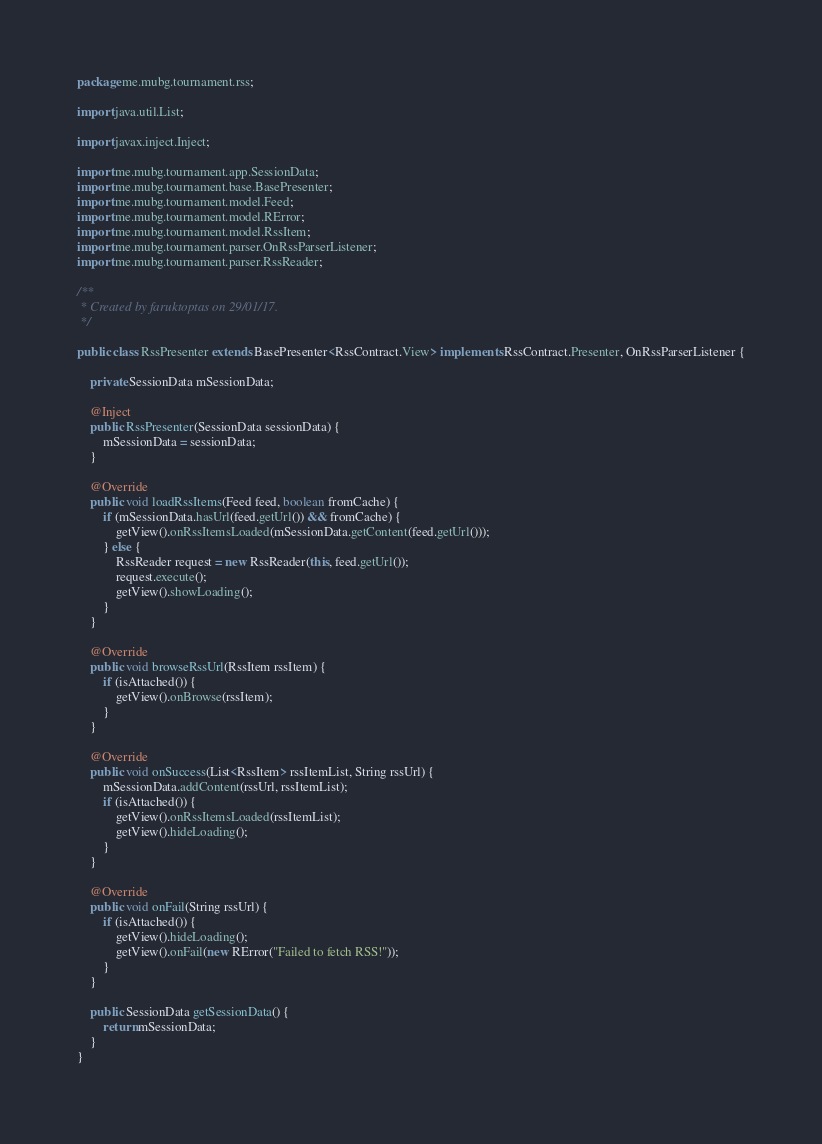<code> <loc_0><loc_0><loc_500><loc_500><_Java_>package me.mubg.tournament.rss;

import java.util.List;

import javax.inject.Inject;

import me.mubg.tournament.app.SessionData;
import me.mubg.tournament.base.BasePresenter;
import me.mubg.tournament.model.Feed;
import me.mubg.tournament.model.RError;
import me.mubg.tournament.model.RssItem;
import me.mubg.tournament.parser.OnRssParserListener;
import me.mubg.tournament.parser.RssReader;

/**
 * Created by faruktoptas on 29/01/17.
 */

public class RssPresenter extends BasePresenter<RssContract.View> implements RssContract.Presenter, OnRssParserListener {

    private SessionData mSessionData;

    @Inject
    public RssPresenter(SessionData sessionData) {
        mSessionData = sessionData;
    }

    @Override
    public void loadRssItems(Feed feed, boolean fromCache) {
        if (mSessionData.hasUrl(feed.getUrl()) && fromCache) {
            getView().onRssItemsLoaded(mSessionData.getContent(feed.getUrl()));
        } else {
            RssReader request = new RssReader(this, feed.getUrl());
            request.execute();
            getView().showLoading();
        }
    }

    @Override
    public void browseRssUrl(RssItem rssItem) {
        if (isAttached()) {
            getView().onBrowse(rssItem);
        }
    }

    @Override
    public void onSuccess(List<RssItem> rssItemList, String rssUrl) {
        mSessionData.addContent(rssUrl, rssItemList);
        if (isAttached()) {
            getView().onRssItemsLoaded(rssItemList);
            getView().hideLoading();
        }
    }

    @Override
    public void onFail(String rssUrl) {
        if (isAttached()) {
            getView().hideLoading();
            getView().onFail(new RError("Failed to fetch RSS!"));
        }
    }

    public SessionData getSessionData() {
        return mSessionData;
    }
}
</code> 